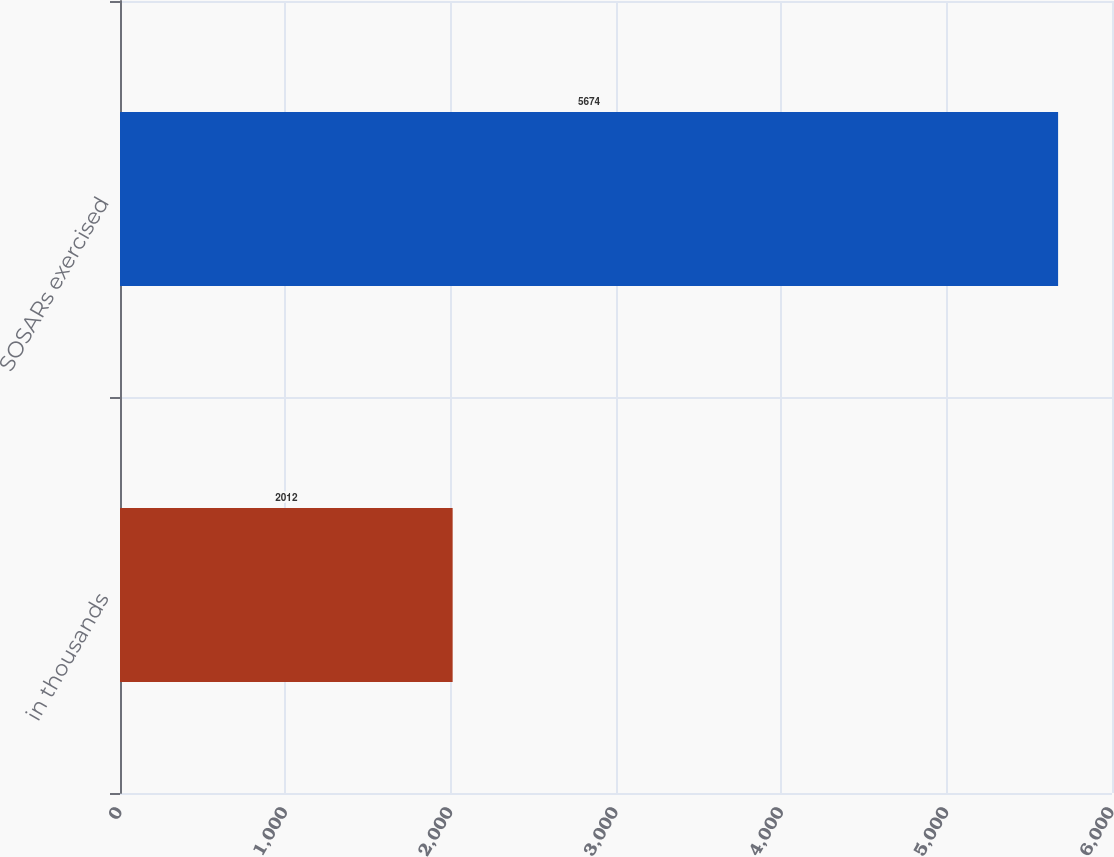Convert chart. <chart><loc_0><loc_0><loc_500><loc_500><bar_chart><fcel>in thousands<fcel>SOSARs exercised<nl><fcel>2012<fcel>5674<nl></chart> 